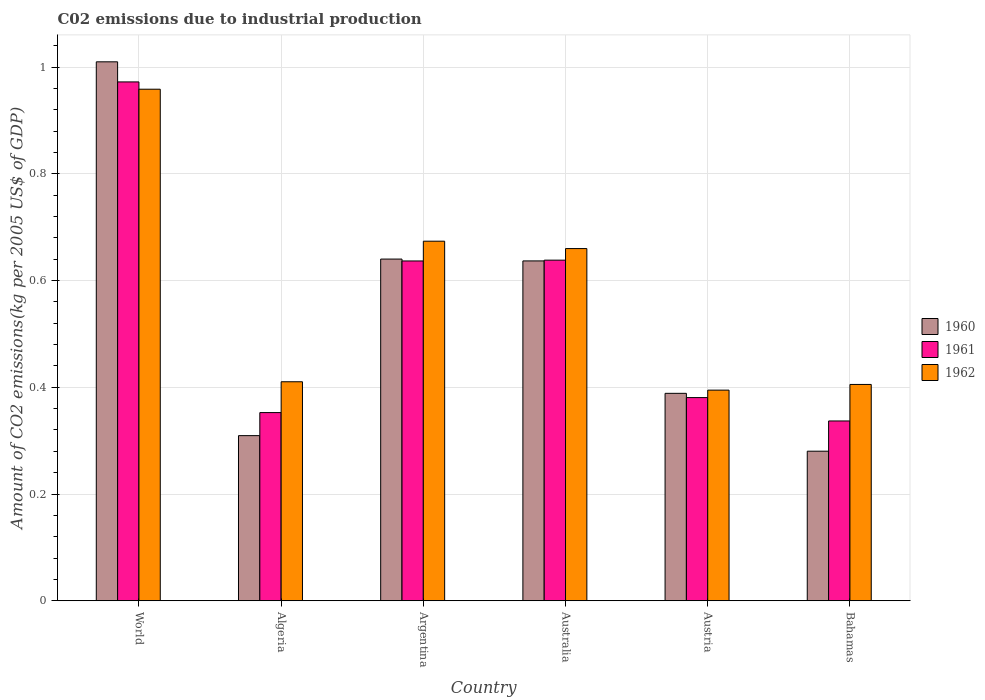How many groups of bars are there?
Your answer should be very brief. 6. Are the number of bars per tick equal to the number of legend labels?
Provide a short and direct response. Yes. Are the number of bars on each tick of the X-axis equal?
Your answer should be compact. Yes. In how many cases, is the number of bars for a given country not equal to the number of legend labels?
Ensure brevity in your answer.  0. What is the amount of CO2 emitted due to industrial production in 1962 in Algeria?
Your answer should be very brief. 0.41. Across all countries, what is the maximum amount of CO2 emitted due to industrial production in 1962?
Provide a short and direct response. 0.96. Across all countries, what is the minimum amount of CO2 emitted due to industrial production in 1961?
Your response must be concise. 0.34. In which country was the amount of CO2 emitted due to industrial production in 1961 minimum?
Your answer should be very brief. Bahamas. What is the total amount of CO2 emitted due to industrial production in 1961 in the graph?
Your answer should be compact. 3.32. What is the difference between the amount of CO2 emitted due to industrial production in 1961 in Algeria and that in Bahamas?
Your answer should be very brief. 0.02. What is the difference between the amount of CO2 emitted due to industrial production in 1960 in Australia and the amount of CO2 emitted due to industrial production in 1961 in Austria?
Make the answer very short. 0.26. What is the average amount of CO2 emitted due to industrial production in 1962 per country?
Keep it short and to the point. 0.58. What is the difference between the amount of CO2 emitted due to industrial production of/in 1962 and amount of CO2 emitted due to industrial production of/in 1961 in Austria?
Keep it short and to the point. 0.01. What is the ratio of the amount of CO2 emitted due to industrial production in 1961 in Algeria to that in Argentina?
Your answer should be compact. 0.55. Is the amount of CO2 emitted due to industrial production in 1960 in Australia less than that in Bahamas?
Keep it short and to the point. No. Is the difference between the amount of CO2 emitted due to industrial production in 1962 in Australia and World greater than the difference between the amount of CO2 emitted due to industrial production in 1961 in Australia and World?
Your response must be concise. Yes. What is the difference between the highest and the second highest amount of CO2 emitted due to industrial production in 1962?
Give a very brief answer. 0.28. What is the difference between the highest and the lowest amount of CO2 emitted due to industrial production in 1962?
Offer a terse response. 0.56. In how many countries, is the amount of CO2 emitted due to industrial production in 1960 greater than the average amount of CO2 emitted due to industrial production in 1960 taken over all countries?
Ensure brevity in your answer.  3. Is it the case that in every country, the sum of the amount of CO2 emitted due to industrial production in 1961 and amount of CO2 emitted due to industrial production in 1962 is greater than the amount of CO2 emitted due to industrial production in 1960?
Offer a terse response. Yes. Are all the bars in the graph horizontal?
Give a very brief answer. No. What is the difference between two consecutive major ticks on the Y-axis?
Keep it short and to the point. 0.2. Does the graph contain any zero values?
Keep it short and to the point. No. Does the graph contain grids?
Offer a terse response. Yes. How are the legend labels stacked?
Provide a succinct answer. Vertical. What is the title of the graph?
Your response must be concise. C02 emissions due to industrial production. What is the label or title of the X-axis?
Provide a short and direct response. Country. What is the label or title of the Y-axis?
Your response must be concise. Amount of CO2 emissions(kg per 2005 US$ of GDP). What is the Amount of CO2 emissions(kg per 2005 US$ of GDP) of 1960 in World?
Provide a succinct answer. 1.01. What is the Amount of CO2 emissions(kg per 2005 US$ of GDP) of 1961 in World?
Your answer should be very brief. 0.97. What is the Amount of CO2 emissions(kg per 2005 US$ of GDP) in 1962 in World?
Your response must be concise. 0.96. What is the Amount of CO2 emissions(kg per 2005 US$ of GDP) in 1960 in Algeria?
Provide a succinct answer. 0.31. What is the Amount of CO2 emissions(kg per 2005 US$ of GDP) in 1961 in Algeria?
Offer a very short reply. 0.35. What is the Amount of CO2 emissions(kg per 2005 US$ of GDP) in 1962 in Algeria?
Your response must be concise. 0.41. What is the Amount of CO2 emissions(kg per 2005 US$ of GDP) of 1960 in Argentina?
Ensure brevity in your answer.  0.64. What is the Amount of CO2 emissions(kg per 2005 US$ of GDP) in 1961 in Argentina?
Your response must be concise. 0.64. What is the Amount of CO2 emissions(kg per 2005 US$ of GDP) in 1962 in Argentina?
Keep it short and to the point. 0.67. What is the Amount of CO2 emissions(kg per 2005 US$ of GDP) in 1960 in Australia?
Offer a terse response. 0.64. What is the Amount of CO2 emissions(kg per 2005 US$ of GDP) in 1961 in Australia?
Offer a very short reply. 0.64. What is the Amount of CO2 emissions(kg per 2005 US$ of GDP) in 1962 in Australia?
Provide a succinct answer. 0.66. What is the Amount of CO2 emissions(kg per 2005 US$ of GDP) in 1960 in Austria?
Keep it short and to the point. 0.39. What is the Amount of CO2 emissions(kg per 2005 US$ of GDP) of 1961 in Austria?
Provide a succinct answer. 0.38. What is the Amount of CO2 emissions(kg per 2005 US$ of GDP) in 1962 in Austria?
Offer a very short reply. 0.39. What is the Amount of CO2 emissions(kg per 2005 US$ of GDP) in 1960 in Bahamas?
Offer a terse response. 0.28. What is the Amount of CO2 emissions(kg per 2005 US$ of GDP) in 1961 in Bahamas?
Your response must be concise. 0.34. What is the Amount of CO2 emissions(kg per 2005 US$ of GDP) in 1962 in Bahamas?
Your answer should be compact. 0.41. Across all countries, what is the maximum Amount of CO2 emissions(kg per 2005 US$ of GDP) of 1960?
Your answer should be compact. 1.01. Across all countries, what is the maximum Amount of CO2 emissions(kg per 2005 US$ of GDP) of 1961?
Offer a very short reply. 0.97. Across all countries, what is the maximum Amount of CO2 emissions(kg per 2005 US$ of GDP) in 1962?
Give a very brief answer. 0.96. Across all countries, what is the minimum Amount of CO2 emissions(kg per 2005 US$ of GDP) in 1960?
Your response must be concise. 0.28. Across all countries, what is the minimum Amount of CO2 emissions(kg per 2005 US$ of GDP) of 1961?
Your response must be concise. 0.34. Across all countries, what is the minimum Amount of CO2 emissions(kg per 2005 US$ of GDP) in 1962?
Ensure brevity in your answer.  0.39. What is the total Amount of CO2 emissions(kg per 2005 US$ of GDP) of 1960 in the graph?
Offer a very short reply. 3.26. What is the total Amount of CO2 emissions(kg per 2005 US$ of GDP) in 1961 in the graph?
Make the answer very short. 3.32. What is the total Amount of CO2 emissions(kg per 2005 US$ of GDP) in 1962 in the graph?
Make the answer very short. 3.5. What is the difference between the Amount of CO2 emissions(kg per 2005 US$ of GDP) in 1960 in World and that in Algeria?
Provide a short and direct response. 0.7. What is the difference between the Amount of CO2 emissions(kg per 2005 US$ of GDP) in 1961 in World and that in Algeria?
Provide a short and direct response. 0.62. What is the difference between the Amount of CO2 emissions(kg per 2005 US$ of GDP) in 1962 in World and that in Algeria?
Keep it short and to the point. 0.55. What is the difference between the Amount of CO2 emissions(kg per 2005 US$ of GDP) in 1960 in World and that in Argentina?
Your answer should be very brief. 0.37. What is the difference between the Amount of CO2 emissions(kg per 2005 US$ of GDP) in 1961 in World and that in Argentina?
Provide a succinct answer. 0.34. What is the difference between the Amount of CO2 emissions(kg per 2005 US$ of GDP) of 1962 in World and that in Argentina?
Provide a succinct answer. 0.28. What is the difference between the Amount of CO2 emissions(kg per 2005 US$ of GDP) in 1960 in World and that in Australia?
Your answer should be very brief. 0.37. What is the difference between the Amount of CO2 emissions(kg per 2005 US$ of GDP) in 1961 in World and that in Australia?
Offer a very short reply. 0.33. What is the difference between the Amount of CO2 emissions(kg per 2005 US$ of GDP) of 1962 in World and that in Australia?
Provide a short and direct response. 0.3. What is the difference between the Amount of CO2 emissions(kg per 2005 US$ of GDP) in 1960 in World and that in Austria?
Give a very brief answer. 0.62. What is the difference between the Amount of CO2 emissions(kg per 2005 US$ of GDP) of 1961 in World and that in Austria?
Keep it short and to the point. 0.59. What is the difference between the Amount of CO2 emissions(kg per 2005 US$ of GDP) of 1962 in World and that in Austria?
Offer a terse response. 0.56. What is the difference between the Amount of CO2 emissions(kg per 2005 US$ of GDP) in 1960 in World and that in Bahamas?
Give a very brief answer. 0.73. What is the difference between the Amount of CO2 emissions(kg per 2005 US$ of GDP) of 1961 in World and that in Bahamas?
Ensure brevity in your answer.  0.64. What is the difference between the Amount of CO2 emissions(kg per 2005 US$ of GDP) in 1962 in World and that in Bahamas?
Ensure brevity in your answer.  0.55. What is the difference between the Amount of CO2 emissions(kg per 2005 US$ of GDP) in 1960 in Algeria and that in Argentina?
Provide a short and direct response. -0.33. What is the difference between the Amount of CO2 emissions(kg per 2005 US$ of GDP) of 1961 in Algeria and that in Argentina?
Offer a very short reply. -0.28. What is the difference between the Amount of CO2 emissions(kg per 2005 US$ of GDP) of 1962 in Algeria and that in Argentina?
Ensure brevity in your answer.  -0.26. What is the difference between the Amount of CO2 emissions(kg per 2005 US$ of GDP) in 1960 in Algeria and that in Australia?
Ensure brevity in your answer.  -0.33. What is the difference between the Amount of CO2 emissions(kg per 2005 US$ of GDP) of 1961 in Algeria and that in Australia?
Make the answer very short. -0.29. What is the difference between the Amount of CO2 emissions(kg per 2005 US$ of GDP) in 1962 in Algeria and that in Australia?
Provide a succinct answer. -0.25. What is the difference between the Amount of CO2 emissions(kg per 2005 US$ of GDP) in 1960 in Algeria and that in Austria?
Provide a succinct answer. -0.08. What is the difference between the Amount of CO2 emissions(kg per 2005 US$ of GDP) of 1961 in Algeria and that in Austria?
Give a very brief answer. -0.03. What is the difference between the Amount of CO2 emissions(kg per 2005 US$ of GDP) in 1962 in Algeria and that in Austria?
Give a very brief answer. 0.02. What is the difference between the Amount of CO2 emissions(kg per 2005 US$ of GDP) of 1960 in Algeria and that in Bahamas?
Provide a short and direct response. 0.03. What is the difference between the Amount of CO2 emissions(kg per 2005 US$ of GDP) in 1961 in Algeria and that in Bahamas?
Your response must be concise. 0.02. What is the difference between the Amount of CO2 emissions(kg per 2005 US$ of GDP) of 1962 in Algeria and that in Bahamas?
Your answer should be very brief. 0.01. What is the difference between the Amount of CO2 emissions(kg per 2005 US$ of GDP) of 1960 in Argentina and that in Australia?
Offer a very short reply. 0. What is the difference between the Amount of CO2 emissions(kg per 2005 US$ of GDP) in 1961 in Argentina and that in Australia?
Your answer should be compact. -0. What is the difference between the Amount of CO2 emissions(kg per 2005 US$ of GDP) in 1962 in Argentina and that in Australia?
Your answer should be compact. 0.01. What is the difference between the Amount of CO2 emissions(kg per 2005 US$ of GDP) in 1960 in Argentina and that in Austria?
Your answer should be very brief. 0.25. What is the difference between the Amount of CO2 emissions(kg per 2005 US$ of GDP) of 1961 in Argentina and that in Austria?
Make the answer very short. 0.26. What is the difference between the Amount of CO2 emissions(kg per 2005 US$ of GDP) in 1962 in Argentina and that in Austria?
Your answer should be very brief. 0.28. What is the difference between the Amount of CO2 emissions(kg per 2005 US$ of GDP) of 1960 in Argentina and that in Bahamas?
Your answer should be very brief. 0.36. What is the difference between the Amount of CO2 emissions(kg per 2005 US$ of GDP) of 1961 in Argentina and that in Bahamas?
Give a very brief answer. 0.3. What is the difference between the Amount of CO2 emissions(kg per 2005 US$ of GDP) of 1962 in Argentina and that in Bahamas?
Your answer should be very brief. 0.27. What is the difference between the Amount of CO2 emissions(kg per 2005 US$ of GDP) of 1960 in Australia and that in Austria?
Give a very brief answer. 0.25. What is the difference between the Amount of CO2 emissions(kg per 2005 US$ of GDP) of 1961 in Australia and that in Austria?
Your answer should be compact. 0.26. What is the difference between the Amount of CO2 emissions(kg per 2005 US$ of GDP) in 1962 in Australia and that in Austria?
Your answer should be very brief. 0.27. What is the difference between the Amount of CO2 emissions(kg per 2005 US$ of GDP) in 1960 in Australia and that in Bahamas?
Make the answer very short. 0.36. What is the difference between the Amount of CO2 emissions(kg per 2005 US$ of GDP) of 1961 in Australia and that in Bahamas?
Keep it short and to the point. 0.3. What is the difference between the Amount of CO2 emissions(kg per 2005 US$ of GDP) in 1962 in Australia and that in Bahamas?
Provide a succinct answer. 0.25. What is the difference between the Amount of CO2 emissions(kg per 2005 US$ of GDP) of 1960 in Austria and that in Bahamas?
Keep it short and to the point. 0.11. What is the difference between the Amount of CO2 emissions(kg per 2005 US$ of GDP) in 1961 in Austria and that in Bahamas?
Ensure brevity in your answer.  0.04. What is the difference between the Amount of CO2 emissions(kg per 2005 US$ of GDP) in 1962 in Austria and that in Bahamas?
Ensure brevity in your answer.  -0.01. What is the difference between the Amount of CO2 emissions(kg per 2005 US$ of GDP) of 1960 in World and the Amount of CO2 emissions(kg per 2005 US$ of GDP) of 1961 in Algeria?
Provide a succinct answer. 0.66. What is the difference between the Amount of CO2 emissions(kg per 2005 US$ of GDP) of 1960 in World and the Amount of CO2 emissions(kg per 2005 US$ of GDP) of 1962 in Algeria?
Offer a terse response. 0.6. What is the difference between the Amount of CO2 emissions(kg per 2005 US$ of GDP) of 1961 in World and the Amount of CO2 emissions(kg per 2005 US$ of GDP) of 1962 in Algeria?
Your response must be concise. 0.56. What is the difference between the Amount of CO2 emissions(kg per 2005 US$ of GDP) of 1960 in World and the Amount of CO2 emissions(kg per 2005 US$ of GDP) of 1961 in Argentina?
Offer a terse response. 0.37. What is the difference between the Amount of CO2 emissions(kg per 2005 US$ of GDP) in 1960 in World and the Amount of CO2 emissions(kg per 2005 US$ of GDP) in 1962 in Argentina?
Provide a short and direct response. 0.34. What is the difference between the Amount of CO2 emissions(kg per 2005 US$ of GDP) of 1961 in World and the Amount of CO2 emissions(kg per 2005 US$ of GDP) of 1962 in Argentina?
Your response must be concise. 0.3. What is the difference between the Amount of CO2 emissions(kg per 2005 US$ of GDP) of 1960 in World and the Amount of CO2 emissions(kg per 2005 US$ of GDP) of 1961 in Australia?
Offer a very short reply. 0.37. What is the difference between the Amount of CO2 emissions(kg per 2005 US$ of GDP) of 1960 in World and the Amount of CO2 emissions(kg per 2005 US$ of GDP) of 1962 in Australia?
Give a very brief answer. 0.35. What is the difference between the Amount of CO2 emissions(kg per 2005 US$ of GDP) of 1961 in World and the Amount of CO2 emissions(kg per 2005 US$ of GDP) of 1962 in Australia?
Provide a succinct answer. 0.31. What is the difference between the Amount of CO2 emissions(kg per 2005 US$ of GDP) of 1960 in World and the Amount of CO2 emissions(kg per 2005 US$ of GDP) of 1961 in Austria?
Your answer should be compact. 0.63. What is the difference between the Amount of CO2 emissions(kg per 2005 US$ of GDP) of 1960 in World and the Amount of CO2 emissions(kg per 2005 US$ of GDP) of 1962 in Austria?
Your answer should be very brief. 0.62. What is the difference between the Amount of CO2 emissions(kg per 2005 US$ of GDP) of 1961 in World and the Amount of CO2 emissions(kg per 2005 US$ of GDP) of 1962 in Austria?
Offer a very short reply. 0.58. What is the difference between the Amount of CO2 emissions(kg per 2005 US$ of GDP) of 1960 in World and the Amount of CO2 emissions(kg per 2005 US$ of GDP) of 1961 in Bahamas?
Provide a succinct answer. 0.67. What is the difference between the Amount of CO2 emissions(kg per 2005 US$ of GDP) of 1960 in World and the Amount of CO2 emissions(kg per 2005 US$ of GDP) of 1962 in Bahamas?
Ensure brevity in your answer.  0.6. What is the difference between the Amount of CO2 emissions(kg per 2005 US$ of GDP) of 1961 in World and the Amount of CO2 emissions(kg per 2005 US$ of GDP) of 1962 in Bahamas?
Give a very brief answer. 0.57. What is the difference between the Amount of CO2 emissions(kg per 2005 US$ of GDP) of 1960 in Algeria and the Amount of CO2 emissions(kg per 2005 US$ of GDP) of 1961 in Argentina?
Give a very brief answer. -0.33. What is the difference between the Amount of CO2 emissions(kg per 2005 US$ of GDP) of 1960 in Algeria and the Amount of CO2 emissions(kg per 2005 US$ of GDP) of 1962 in Argentina?
Keep it short and to the point. -0.36. What is the difference between the Amount of CO2 emissions(kg per 2005 US$ of GDP) of 1961 in Algeria and the Amount of CO2 emissions(kg per 2005 US$ of GDP) of 1962 in Argentina?
Give a very brief answer. -0.32. What is the difference between the Amount of CO2 emissions(kg per 2005 US$ of GDP) of 1960 in Algeria and the Amount of CO2 emissions(kg per 2005 US$ of GDP) of 1961 in Australia?
Provide a succinct answer. -0.33. What is the difference between the Amount of CO2 emissions(kg per 2005 US$ of GDP) in 1960 in Algeria and the Amount of CO2 emissions(kg per 2005 US$ of GDP) in 1962 in Australia?
Provide a succinct answer. -0.35. What is the difference between the Amount of CO2 emissions(kg per 2005 US$ of GDP) of 1961 in Algeria and the Amount of CO2 emissions(kg per 2005 US$ of GDP) of 1962 in Australia?
Your answer should be compact. -0.31. What is the difference between the Amount of CO2 emissions(kg per 2005 US$ of GDP) of 1960 in Algeria and the Amount of CO2 emissions(kg per 2005 US$ of GDP) of 1961 in Austria?
Your answer should be very brief. -0.07. What is the difference between the Amount of CO2 emissions(kg per 2005 US$ of GDP) in 1960 in Algeria and the Amount of CO2 emissions(kg per 2005 US$ of GDP) in 1962 in Austria?
Your response must be concise. -0.09. What is the difference between the Amount of CO2 emissions(kg per 2005 US$ of GDP) in 1961 in Algeria and the Amount of CO2 emissions(kg per 2005 US$ of GDP) in 1962 in Austria?
Offer a terse response. -0.04. What is the difference between the Amount of CO2 emissions(kg per 2005 US$ of GDP) in 1960 in Algeria and the Amount of CO2 emissions(kg per 2005 US$ of GDP) in 1961 in Bahamas?
Keep it short and to the point. -0.03. What is the difference between the Amount of CO2 emissions(kg per 2005 US$ of GDP) of 1960 in Algeria and the Amount of CO2 emissions(kg per 2005 US$ of GDP) of 1962 in Bahamas?
Your response must be concise. -0.1. What is the difference between the Amount of CO2 emissions(kg per 2005 US$ of GDP) in 1961 in Algeria and the Amount of CO2 emissions(kg per 2005 US$ of GDP) in 1962 in Bahamas?
Your response must be concise. -0.05. What is the difference between the Amount of CO2 emissions(kg per 2005 US$ of GDP) in 1960 in Argentina and the Amount of CO2 emissions(kg per 2005 US$ of GDP) in 1961 in Australia?
Ensure brevity in your answer.  0. What is the difference between the Amount of CO2 emissions(kg per 2005 US$ of GDP) in 1960 in Argentina and the Amount of CO2 emissions(kg per 2005 US$ of GDP) in 1962 in Australia?
Your response must be concise. -0.02. What is the difference between the Amount of CO2 emissions(kg per 2005 US$ of GDP) of 1961 in Argentina and the Amount of CO2 emissions(kg per 2005 US$ of GDP) of 1962 in Australia?
Offer a very short reply. -0.02. What is the difference between the Amount of CO2 emissions(kg per 2005 US$ of GDP) of 1960 in Argentina and the Amount of CO2 emissions(kg per 2005 US$ of GDP) of 1961 in Austria?
Your response must be concise. 0.26. What is the difference between the Amount of CO2 emissions(kg per 2005 US$ of GDP) of 1960 in Argentina and the Amount of CO2 emissions(kg per 2005 US$ of GDP) of 1962 in Austria?
Keep it short and to the point. 0.25. What is the difference between the Amount of CO2 emissions(kg per 2005 US$ of GDP) in 1961 in Argentina and the Amount of CO2 emissions(kg per 2005 US$ of GDP) in 1962 in Austria?
Your answer should be very brief. 0.24. What is the difference between the Amount of CO2 emissions(kg per 2005 US$ of GDP) in 1960 in Argentina and the Amount of CO2 emissions(kg per 2005 US$ of GDP) in 1961 in Bahamas?
Offer a terse response. 0.3. What is the difference between the Amount of CO2 emissions(kg per 2005 US$ of GDP) in 1960 in Argentina and the Amount of CO2 emissions(kg per 2005 US$ of GDP) in 1962 in Bahamas?
Provide a succinct answer. 0.23. What is the difference between the Amount of CO2 emissions(kg per 2005 US$ of GDP) of 1961 in Argentina and the Amount of CO2 emissions(kg per 2005 US$ of GDP) of 1962 in Bahamas?
Offer a terse response. 0.23. What is the difference between the Amount of CO2 emissions(kg per 2005 US$ of GDP) of 1960 in Australia and the Amount of CO2 emissions(kg per 2005 US$ of GDP) of 1961 in Austria?
Offer a very short reply. 0.26. What is the difference between the Amount of CO2 emissions(kg per 2005 US$ of GDP) in 1960 in Australia and the Amount of CO2 emissions(kg per 2005 US$ of GDP) in 1962 in Austria?
Give a very brief answer. 0.24. What is the difference between the Amount of CO2 emissions(kg per 2005 US$ of GDP) of 1961 in Australia and the Amount of CO2 emissions(kg per 2005 US$ of GDP) of 1962 in Austria?
Make the answer very short. 0.24. What is the difference between the Amount of CO2 emissions(kg per 2005 US$ of GDP) in 1960 in Australia and the Amount of CO2 emissions(kg per 2005 US$ of GDP) in 1961 in Bahamas?
Make the answer very short. 0.3. What is the difference between the Amount of CO2 emissions(kg per 2005 US$ of GDP) of 1960 in Australia and the Amount of CO2 emissions(kg per 2005 US$ of GDP) of 1962 in Bahamas?
Provide a succinct answer. 0.23. What is the difference between the Amount of CO2 emissions(kg per 2005 US$ of GDP) in 1961 in Australia and the Amount of CO2 emissions(kg per 2005 US$ of GDP) in 1962 in Bahamas?
Your answer should be compact. 0.23. What is the difference between the Amount of CO2 emissions(kg per 2005 US$ of GDP) of 1960 in Austria and the Amount of CO2 emissions(kg per 2005 US$ of GDP) of 1961 in Bahamas?
Provide a succinct answer. 0.05. What is the difference between the Amount of CO2 emissions(kg per 2005 US$ of GDP) in 1960 in Austria and the Amount of CO2 emissions(kg per 2005 US$ of GDP) in 1962 in Bahamas?
Your answer should be very brief. -0.02. What is the difference between the Amount of CO2 emissions(kg per 2005 US$ of GDP) in 1961 in Austria and the Amount of CO2 emissions(kg per 2005 US$ of GDP) in 1962 in Bahamas?
Provide a short and direct response. -0.02. What is the average Amount of CO2 emissions(kg per 2005 US$ of GDP) of 1960 per country?
Offer a very short reply. 0.54. What is the average Amount of CO2 emissions(kg per 2005 US$ of GDP) in 1961 per country?
Your response must be concise. 0.55. What is the average Amount of CO2 emissions(kg per 2005 US$ of GDP) in 1962 per country?
Give a very brief answer. 0.58. What is the difference between the Amount of CO2 emissions(kg per 2005 US$ of GDP) in 1960 and Amount of CO2 emissions(kg per 2005 US$ of GDP) in 1961 in World?
Offer a very short reply. 0.04. What is the difference between the Amount of CO2 emissions(kg per 2005 US$ of GDP) of 1960 and Amount of CO2 emissions(kg per 2005 US$ of GDP) of 1962 in World?
Your response must be concise. 0.05. What is the difference between the Amount of CO2 emissions(kg per 2005 US$ of GDP) of 1961 and Amount of CO2 emissions(kg per 2005 US$ of GDP) of 1962 in World?
Give a very brief answer. 0.01. What is the difference between the Amount of CO2 emissions(kg per 2005 US$ of GDP) in 1960 and Amount of CO2 emissions(kg per 2005 US$ of GDP) in 1961 in Algeria?
Offer a very short reply. -0.04. What is the difference between the Amount of CO2 emissions(kg per 2005 US$ of GDP) in 1960 and Amount of CO2 emissions(kg per 2005 US$ of GDP) in 1962 in Algeria?
Your response must be concise. -0.1. What is the difference between the Amount of CO2 emissions(kg per 2005 US$ of GDP) in 1961 and Amount of CO2 emissions(kg per 2005 US$ of GDP) in 1962 in Algeria?
Make the answer very short. -0.06. What is the difference between the Amount of CO2 emissions(kg per 2005 US$ of GDP) in 1960 and Amount of CO2 emissions(kg per 2005 US$ of GDP) in 1961 in Argentina?
Make the answer very short. 0. What is the difference between the Amount of CO2 emissions(kg per 2005 US$ of GDP) in 1960 and Amount of CO2 emissions(kg per 2005 US$ of GDP) in 1962 in Argentina?
Your response must be concise. -0.03. What is the difference between the Amount of CO2 emissions(kg per 2005 US$ of GDP) of 1961 and Amount of CO2 emissions(kg per 2005 US$ of GDP) of 1962 in Argentina?
Provide a succinct answer. -0.04. What is the difference between the Amount of CO2 emissions(kg per 2005 US$ of GDP) in 1960 and Amount of CO2 emissions(kg per 2005 US$ of GDP) in 1961 in Australia?
Offer a terse response. -0. What is the difference between the Amount of CO2 emissions(kg per 2005 US$ of GDP) in 1960 and Amount of CO2 emissions(kg per 2005 US$ of GDP) in 1962 in Australia?
Provide a succinct answer. -0.02. What is the difference between the Amount of CO2 emissions(kg per 2005 US$ of GDP) of 1961 and Amount of CO2 emissions(kg per 2005 US$ of GDP) of 1962 in Australia?
Keep it short and to the point. -0.02. What is the difference between the Amount of CO2 emissions(kg per 2005 US$ of GDP) in 1960 and Amount of CO2 emissions(kg per 2005 US$ of GDP) in 1961 in Austria?
Give a very brief answer. 0.01. What is the difference between the Amount of CO2 emissions(kg per 2005 US$ of GDP) of 1960 and Amount of CO2 emissions(kg per 2005 US$ of GDP) of 1962 in Austria?
Keep it short and to the point. -0.01. What is the difference between the Amount of CO2 emissions(kg per 2005 US$ of GDP) in 1961 and Amount of CO2 emissions(kg per 2005 US$ of GDP) in 1962 in Austria?
Offer a terse response. -0.01. What is the difference between the Amount of CO2 emissions(kg per 2005 US$ of GDP) of 1960 and Amount of CO2 emissions(kg per 2005 US$ of GDP) of 1961 in Bahamas?
Your response must be concise. -0.06. What is the difference between the Amount of CO2 emissions(kg per 2005 US$ of GDP) of 1960 and Amount of CO2 emissions(kg per 2005 US$ of GDP) of 1962 in Bahamas?
Make the answer very short. -0.13. What is the difference between the Amount of CO2 emissions(kg per 2005 US$ of GDP) of 1961 and Amount of CO2 emissions(kg per 2005 US$ of GDP) of 1962 in Bahamas?
Offer a very short reply. -0.07. What is the ratio of the Amount of CO2 emissions(kg per 2005 US$ of GDP) of 1960 in World to that in Algeria?
Provide a succinct answer. 3.26. What is the ratio of the Amount of CO2 emissions(kg per 2005 US$ of GDP) of 1961 in World to that in Algeria?
Ensure brevity in your answer.  2.76. What is the ratio of the Amount of CO2 emissions(kg per 2005 US$ of GDP) of 1962 in World to that in Algeria?
Your response must be concise. 2.34. What is the ratio of the Amount of CO2 emissions(kg per 2005 US$ of GDP) in 1960 in World to that in Argentina?
Keep it short and to the point. 1.58. What is the ratio of the Amount of CO2 emissions(kg per 2005 US$ of GDP) in 1961 in World to that in Argentina?
Make the answer very short. 1.53. What is the ratio of the Amount of CO2 emissions(kg per 2005 US$ of GDP) of 1962 in World to that in Argentina?
Keep it short and to the point. 1.42. What is the ratio of the Amount of CO2 emissions(kg per 2005 US$ of GDP) of 1960 in World to that in Australia?
Provide a succinct answer. 1.59. What is the ratio of the Amount of CO2 emissions(kg per 2005 US$ of GDP) of 1961 in World to that in Australia?
Offer a terse response. 1.52. What is the ratio of the Amount of CO2 emissions(kg per 2005 US$ of GDP) of 1962 in World to that in Australia?
Your answer should be compact. 1.45. What is the ratio of the Amount of CO2 emissions(kg per 2005 US$ of GDP) of 1960 in World to that in Austria?
Your response must be concise. 2.6. What is the ratio of the Amount of CO2 emissions(kg per 2005 US$ of GDP) in 1961 in World to that in Austria?
Offer a very short reply. 2.55. What is the ratio of the Amount of CO2 emissions(kg per 2005 US$ of GDP) in 1962 in World to that in Austria?
Keep it short and to the point. 2.43. What is the ratio of the Amount of CO2 emissions(kg per 2005 US$ of GDP) in 1960 in World to that in Bahamas?
Provide a short and direct response. 3.6. What is the ratio of the Amount of CO2 emissions(kg per 2005 US$ of GDP) in 1961 in World to that in Bahamas?
Give a very brief answer. 2.89. What is the ratio of the Amount of CO2 emissions(kg per 2005 US$ of GDP) in 1962 in World to that in Bahamas?
Your answer should be very brief. 2.36. What is the ratio of the Amount of CO2 emissions(kg per 2005 US$ of GDP) of 1960 in Algeria to that in Argentina?
Keep it short and to the point. 0.48. What is the ratio of the Amount of CO2 emissions(kg per 2005 US$ of GDP) of 1961 in Algeria to that in Argentina?
Your response must be concise. 0.55. What is the ratio of the Amount of CO2 emissions(kg per 2005 US$ of GDP) of 1962 in Algeria to that in Argentina?
Give a very brief answer. 0.61. What is the ratio of the Amount of CO2 emissions(kg per 2005 US$ of GDP) of 1960 in Algeria to that in Australia?
Provide a short and direct response. 0.49. What is the ratio of the Amount of CO2 emissions(kg per 2005 US$ of GDP) of 1961 in Algeria to that in Australia?
Your response must be concise. 0.55. What is the ratio of the Amount of CO2 emissions(kg per 2005 US$ of GDP) in 1962 in Algeria to that in Australia?
Your answer should be very brief. 0.62. What is the ratio of the Amount of CO2 emissions(kg per 2005 US$ of GDP) in 1960 in Algeria to that in Austria?
Your answer should be very brief. 0.8. What is the ratio of the Amount of CO2 emissions(kg per 2005 US$ of GDP) in 1961 in Algeria to that in Austria?
Your response must be concise. 0.93. What is the ratio of the Amount of CO2 emissions(kg per 2005 US$ of GDP) in 1962 in Algeria to that in Austria?
Offer a very short reply. 1.04. What is the ratio of the Amount of CO2 emissions(kg per 2005 US$ of GDP) in 1960 in Algeria to that in Bahamas?
Your answer should be compact. 1.1. What is the ratio of the Amount of CO2 emissions(kg per 2005 US$ of GDP) in 1961 in Algeria to that in Bahamas?
Make the answer very short. 1.05. What is the ratio of the Amount of CO2 emissions(kg per 2005 US$ of GDP) in 1962 in Algeria to that in Bahamas?
Provide a succinct answer. 1.01. What is the ratio of the Amount of CO2 emissions(kg per 2005 US$ of GDP) in 1960 in Argentina to that in Australia?
Provide a succinct answer. 1.01. What is the ratio of the Amount of CO2 emissions(kg per 2005 US$ of GDP) in 1961 in Argentina to that in Australia?
Your response must be concise. 1. What is the ratio of the Amount of CO2 emissions(kg per 2005 US$ of GDP) in 1962 in Argentina to that in Australia?
Your answer should be compact. 1.02. What is the ratio of the Amount of CO2 emissions(kg per 2005 US$ of GDP) in 1960 in Argentina to that in Austria?
Give a very brief answer. 1.65. What is the ratio of the Amount of CO2 emissions(kg per 2005 US$ of GDP) in 1961 in Argentina to that in Austria?
Keep it short and to the point. 1.67. What is the ratio of the Amount of CO2 emissions(kg per 2005 US$ of GDP) of 1962 in Argentina to that in Austria?
Provide a short and direct response. 1.71. What is the ratio of the Amount of CO2 emissions(kg per 2005 US$ of GDP) in 1960 in Argentina to that in Bahamas?
Provide a succinct answer. 2.28. What is the ratio of the Amount of CO2 emissions(kg per 2005 US$ of GDP) of 1961 in Argentina to that in Bahamas?
Make the answer very short. 1.89. What is the ratio of the Amount of CO2 emissions(kg per 2005 US$ of GDP) in 1962 in Argentina to that in Bahamas?
Your response must be concise. 1.66. What is the ratio of the Amount of CO2 emissions(kg per 2005 US$ of GDP) of 1960 in Australia to that in Austria?
Offer a terse response. 1.64. What is the ratio of the Amount of CO2 emissions(kg per 2005 US$ of GDP) in 1961 in Australia to that in Austria?
Keep it short and to the point. 1.68. What is the ratio of the Amount of CO2 emissions(kg per 2005 US$ of GDP) in 1962 in Australia to that in Austria?
Provide a succinct answer. 1.67. What is the ratio of the Amount of CO2 emissions(kg per 2005 US$ of GDP) in 1960 in Australia to that in Bahamas?
Your answer should be very brief. 2.27. What is the ratio of the Amount of CO2 emissions(kg per 2005 US$ of GDP) in 1961 in Australia to that in Bahamas?
Your answer should be very brief. 1.89. What is the ratio of the Amount of CO2 emissions(kg per 2005 US$ of GDP) in 1962 in Australia to that in Bahamas?
Your response must be concise. 1.63. What is the ratio of the Amount of CO2 emissions(kg per 2005 US$ of GDP) in 1960 in Austria to that in Bahamas?
Offer a very short reply. 1.39. What is the ratio of the Amount of CO2 emissions(kg per 2005 US$ of GDP) of 1961 in Austria to that in Bahamas?
Make the answer very short. 1.13. What is the ratio of the Amount of CO2 emissions(kg per 2005 US$ of GDP) of 1962 in Austria to that in Bahamas?
Your response must be concise. 0.97. What is the difference between the highest and the second highest Amount of CO2 emissions(kg per 2005 US$ of GDP) in 1960?
Offer a very short reply. 0.37. What is the difference between the highest and the second highest Amount of CO2 emissions(kg per 2005 US$ of GDP) of 1961?
Provide a short and direct response. 0.33. What is the difference between the highest and the second highest Amount of CO2 emissions(kg per 2005 US$ of GDP) of 1962?
Your answer should be compact. 0.28. What is the difference between the highest and the lowest Amount of CO2 emissions(kg per 2005 US$ of GDP) of 1960?
Your answer should be compact. 0.73. What is the difference between the highest and the lowest Amount of CO2 emissions(kg per 2005 US$ of GDP) in 1961?
Ensure brevity in your answer.  0.64. What is the difference between the highest and the lowest Amount of CO2 emissions(kg per 2005 US$ of GDP) in 1962?
Your answer should be very brief. 0.56. 